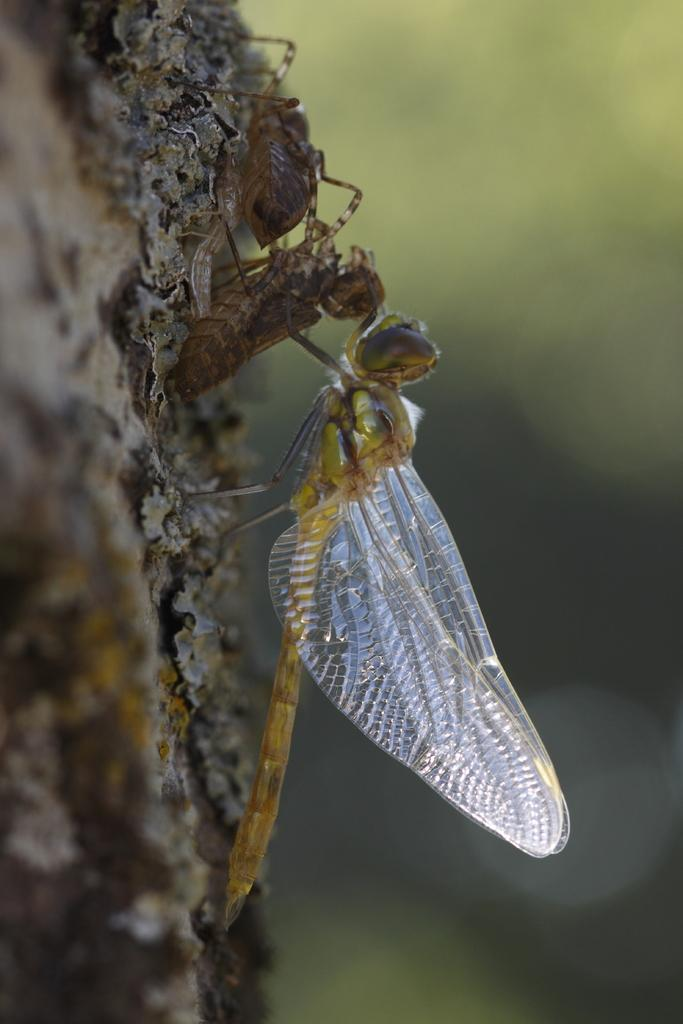What insects can be seen in the image? There is a dragonfly and an ant in the image. Can you describe the appearance of the dragonfly? The dragonfly has wings and a long, slender body. What is the other insect in the image? The other insect is an ant. What type of mask is the dragonfly wearing in the image? There is no mask present on the dragonfly in the image. What society does the ant belong to in the image? The image does not provide information about the ant's society. What holiday is being celebrated in the image? The image does not depict a holiday or any celebratory activities. 